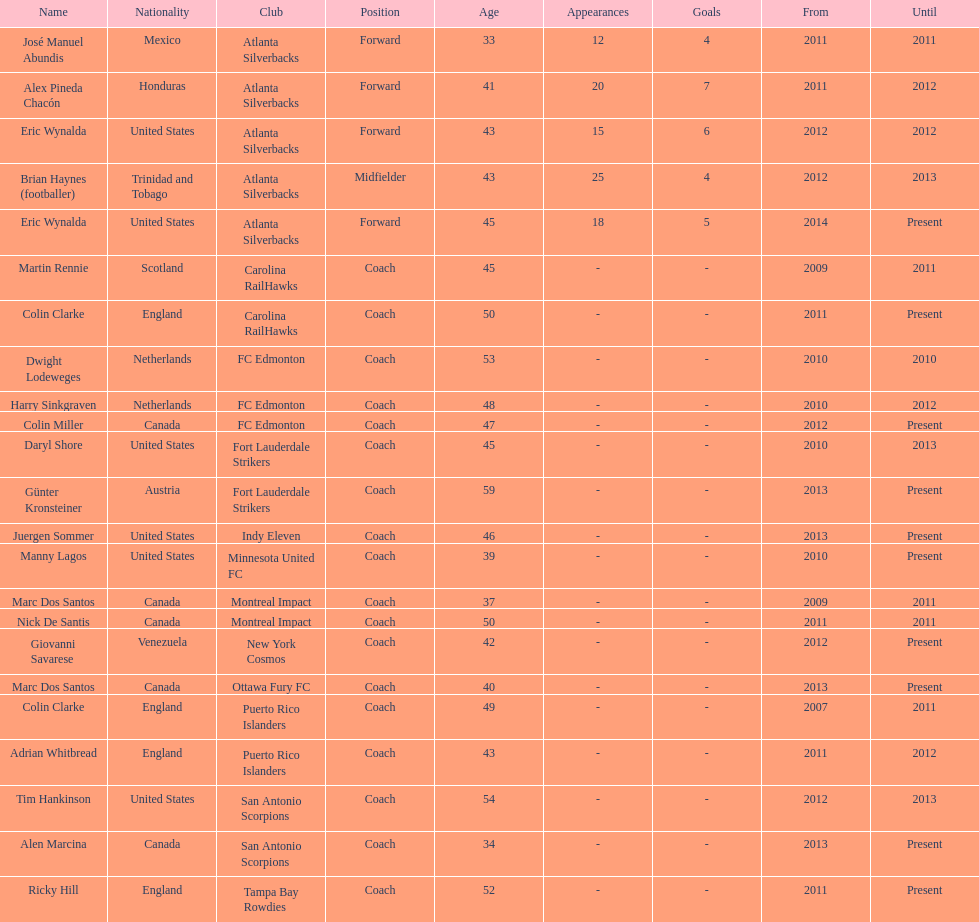Who is the last to coach the san antonio scorpions? Alen Marcina. 